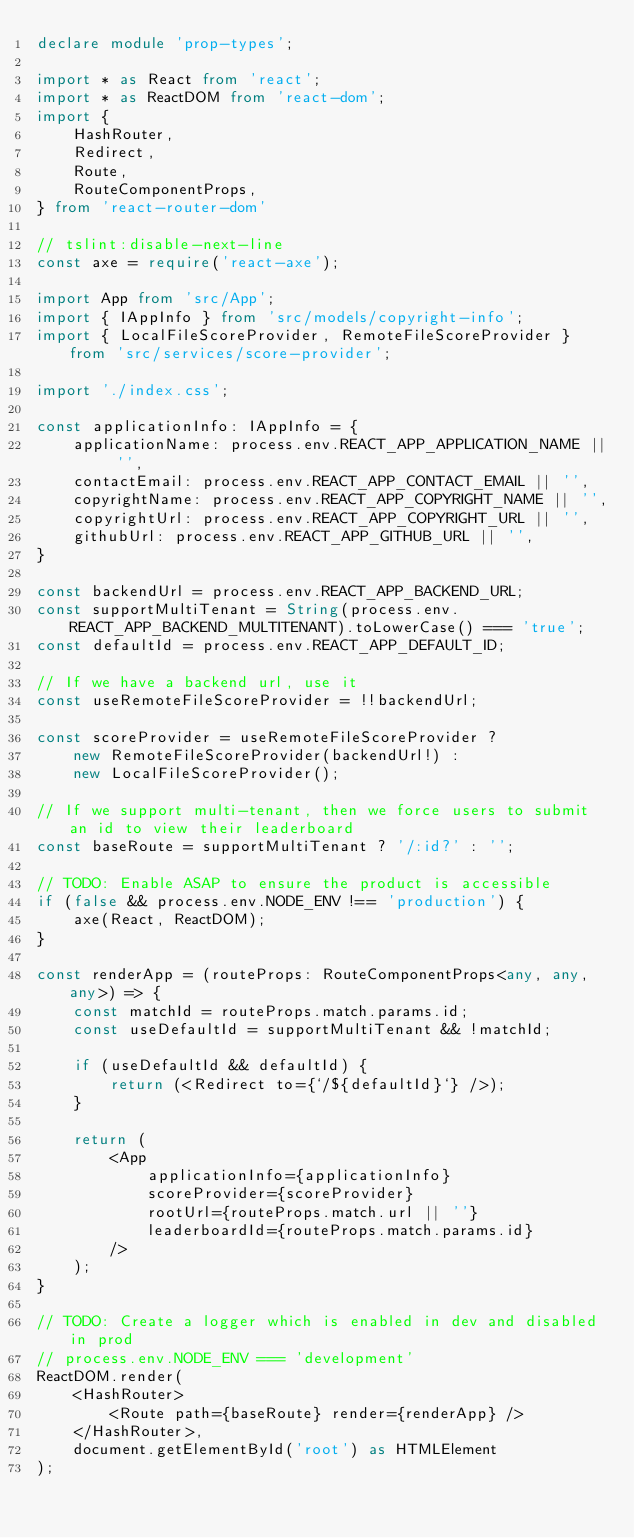Convert code to text. <code><loc_0><loc_0><loc_500><loc_500><_TypeScript_>declare module 'prop-types';

import * as React from 'react';
import * as ReactDOM from 'react-dom';
import {
    HashRouter,
    Redirect,
    Route,
    RouteComponentProps,
} from 'react-router-dom'

// tslint:disable-next-line
const axe = require('react-axe');

import App from 'src/App';
import { IAppInfo } from 'src/models/copyright-info';
import { LocalFileScoreProvider, RemoteFileScoreProvider } from 'src/services/score-provider';

import './index.css';

const applicationInfo: IAppInfo = {
    applicationName: process.env.REACT_APP_APPLICATION_NAME || '',
    contactEmail: process.env.REACT_APP_CONTACT_EMAIL || '',
    copyrightName: process.env.REACT_APP_COPYRIGHT_NAME || '',
    copyrightUrl: process.env.REACT_APP_COPYRIGHT_URL || '',
    githubUrl: process.env.REACT_APP_GITHUB_URL || '',
}

const backendUrl = process.env.REACT_APP_BACKEND_URL;
const supportMultiTenant = String(process.env.REACT_APP_BACKEND_MULTITENANT).toLowerCase() === 'true';
const defaultId = process.env.REACT_APP_DEFAULT_ID;

// If we have a backend url, use it
const useRemoteFileScoreProvider = !!backendUrl;

const scoreProvider = useRemoteFileScoreProvider ?
    new RemoteFileScoreProvider(backendUrl!) :
    new LocalFileScoreProvider();

// If we support multi-tenant, then we force users to submit an id to view their leaderboard
const baseRoute = supportMultiTenant ? '/:id?' : '';

// TODO: Enable ASAP to ensure the product is accessible
if (false && process.env.NODE_ENV !== 'production') {
    axe(React, ReactDOM);
}

const renderApp = (routeProps: RouteComponentProps<any, any, any>) => {
    const matchId = routeProps.match.params.id;
    const useDefaultId = supportMultiTenant && !matchId;

    if (useDefaultId && defaultId) {
        return (<Redirect to={`/${defaultId}`} />);
    }

    return (
        <App
            applicationInfo={applicationInfo}
            scoreProvider={scoreProvider}
            rootUrl={routeProps.match.url || ''}
            leaderboardId={routeProps.match.params.id}
        />
    );
}

// TODO: Create a logger which is enabled in dev and disabled in prod
// process.env.NODE_ENV === 'development'
ReactDOM.render(
    <HashRouter>
        <Route path={baseRoute} render={renderApp} />
    </HashRouter>,
    document.getElementById('root') as HTMLElement
);
</code> 